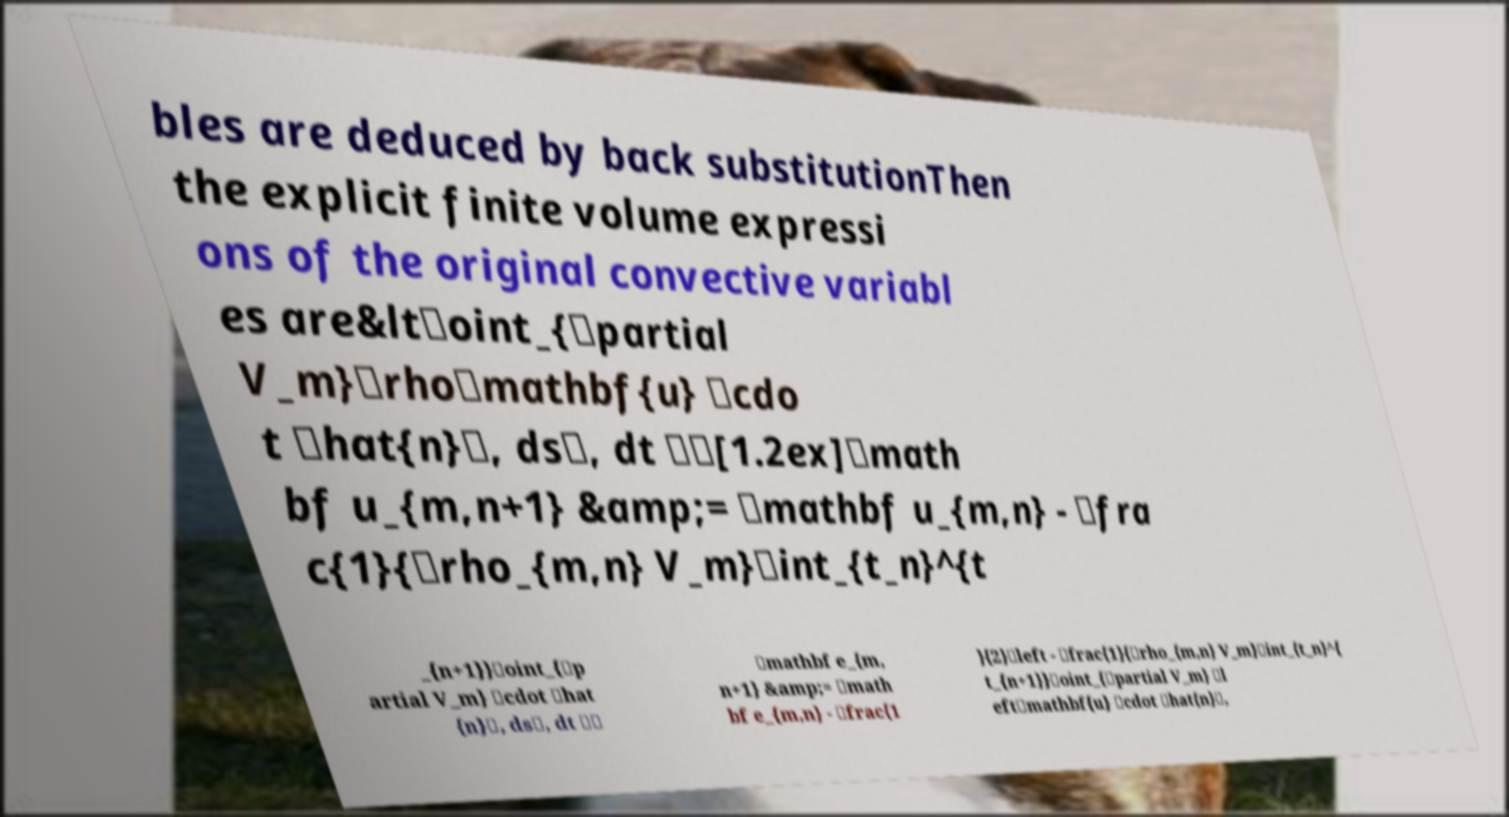Could you assist in decoding the text presented in this image and type it out clearly? bles are deduced by back substitutionThen the explicit finite volume expressi ons of the original convective variabl es are&lt\oint_{\partial V_m}\rho\mathbf{u} \cdo t \hat{n}\, ds\, dt \\[1.2ex]\math bf u_{m,n+1} &amp;= \mathbf u_{m,n} - \fra c{1}{\rho_{m,n} V_m}\int_{t_n}^{t _{n+1}}\oint_{\p artial V_m} \cdot \hat {n}\, ds\, dt \\ \mathbf e_{m, n+1} &amp;= \math bf e_{m,n} - \frac{1 }{2}\left - \frac{1}{\rho_{m,n} V_m}\int_{t_n}^{ t_{n+1}}\oint_{\partial V_m} \l eft\mathbf{u} \cdot \hat{n}\, 